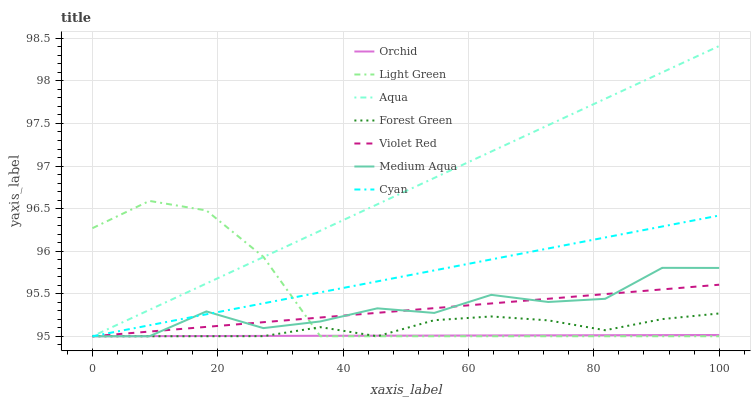Does Orchid have the minimum area under the curve?
Answer yes or no. Yes. Does Aqua have the maximum area under the curve?
Answer yes or no. Yes. Does Forest Green have the minimum area under the curve?
Answer yes or no. No. Does Forest Green have the maximum area under the curve?
Answer yes or no. No. Is Aqua the smoothest?
Answer yes or no. Yes. Is Medium Aqua the roughest?
Answer yes or no. Yes. Is Forest Green the smoothest?
Answer yes or no. No. Is Forest Green the roughest?
Answer yes or no. No. Does Violet Red have the lowest value?
Answer yes or no. Yes. Does Aqua have the highest value?
Answer yes or no. Yes. Does Forest Green have the highest value?
Answer yes or no. No. Does Cyan intersect Violet Red?
Answer yes or no. Yes. Is Cyan less than Violet Red?
Answer yes or no. No. Is Cyan greater than Violet Red?
Answer yes or no. No. 